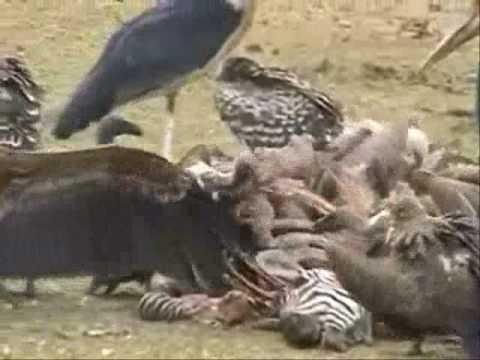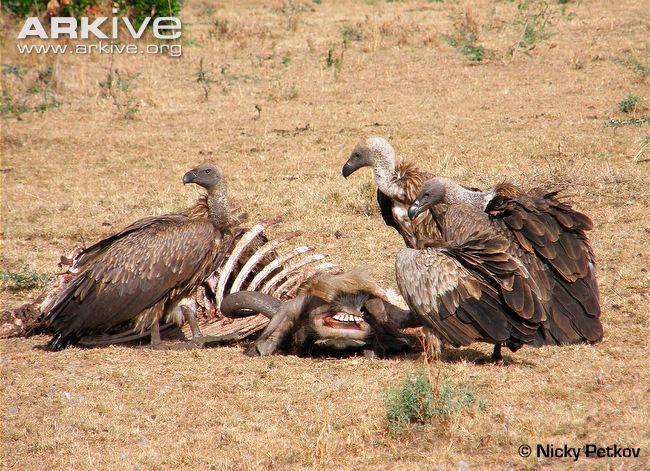The first image is the image on the left, the second image is the image on the right. For the images shown, is this caption "The birds can be seen picking at the striped fur and remains of a zebra in one of the images." true? Answer yes or no. Yes. The first image is the image on the left, the second image is the image on the right. Evaluate the accuracy of this statement regarding the images: "An image shows vultures around a zebra carcass with some of its striped hide visible.". Is it true? Answer yes or no. Yes. 